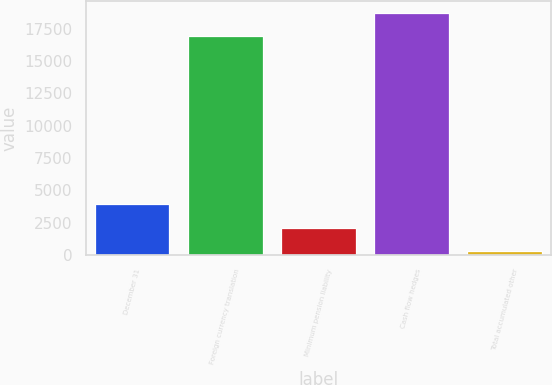<chart> <loc_0><loc_0><loc_500><loc_500><bar_chart><fcel>December 31<fcel>Foreign currency translation<fcel>Minimum pension liability<fcel>Cash flow hedges<fcel>Total accumulated other<nl><fcel>3916.4<fcel>16908<fcel>2112.7<fcel>18711.7<fcel>309<nl></chart> 